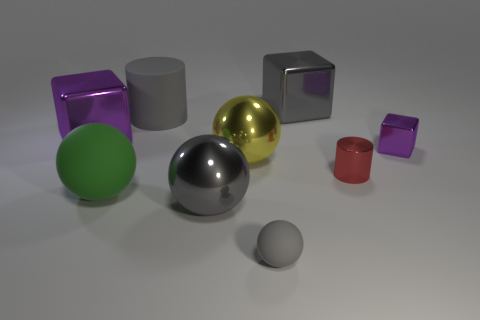Can you tell me which of these objects would be the heaviest assuming they are all made of the same material? If all these objects were made of the same material, the largest one by volume would be the heaviest. In this case, it's the large green, sphere-like object in the center. Its size outweighs the others, making it the heaviest if the material density is constant across all items. 